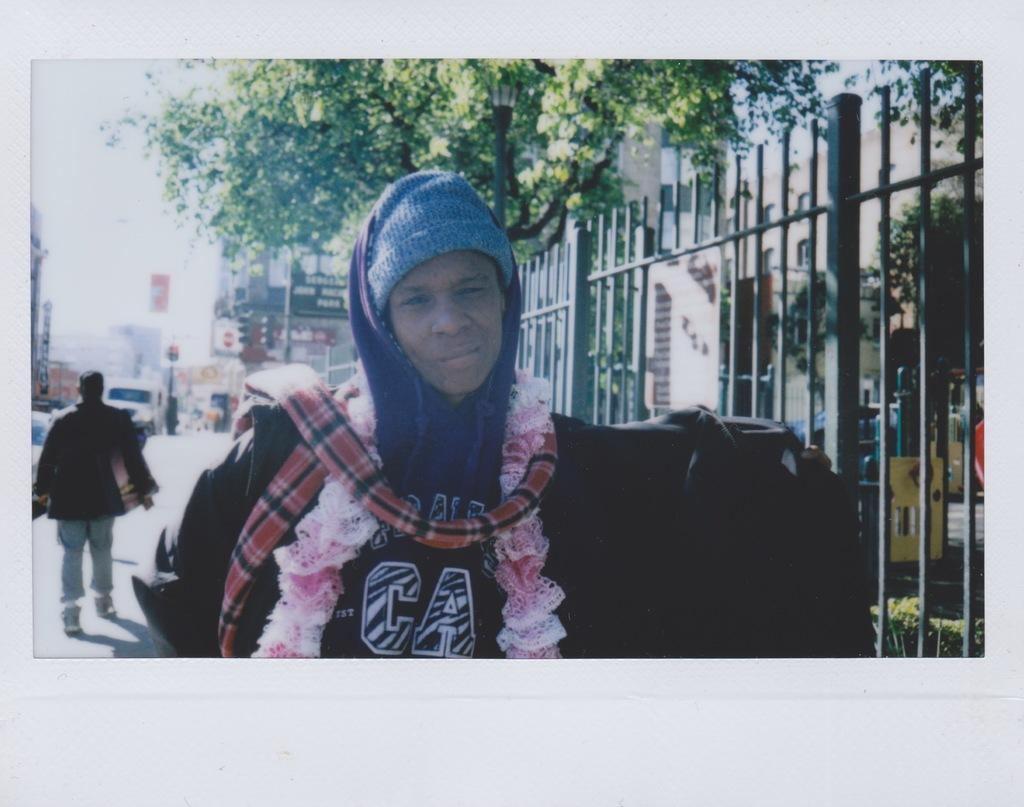<image>
Provide a brief description of the given image. A man in a sweater that says CA poses for a photo. 